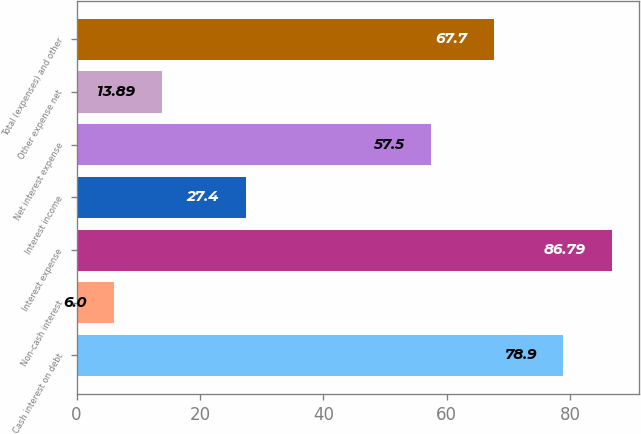<chart> <loc_0><loc_0><loc_500><loc_500><bar_chart><fcel>Cash interest on debt<fcel>Non-cash interest<fcel>Interest expense<fcel>Interest income<fcel>Net interest expense<fcel>Other expense net<fcel>Total (expenses) and other<nl><fcel>78.9<fcel>6<fcel>86.79<fcel>27.4<fcel>57.5<fcel>13.89<fcel>67.7<nl></chart> 